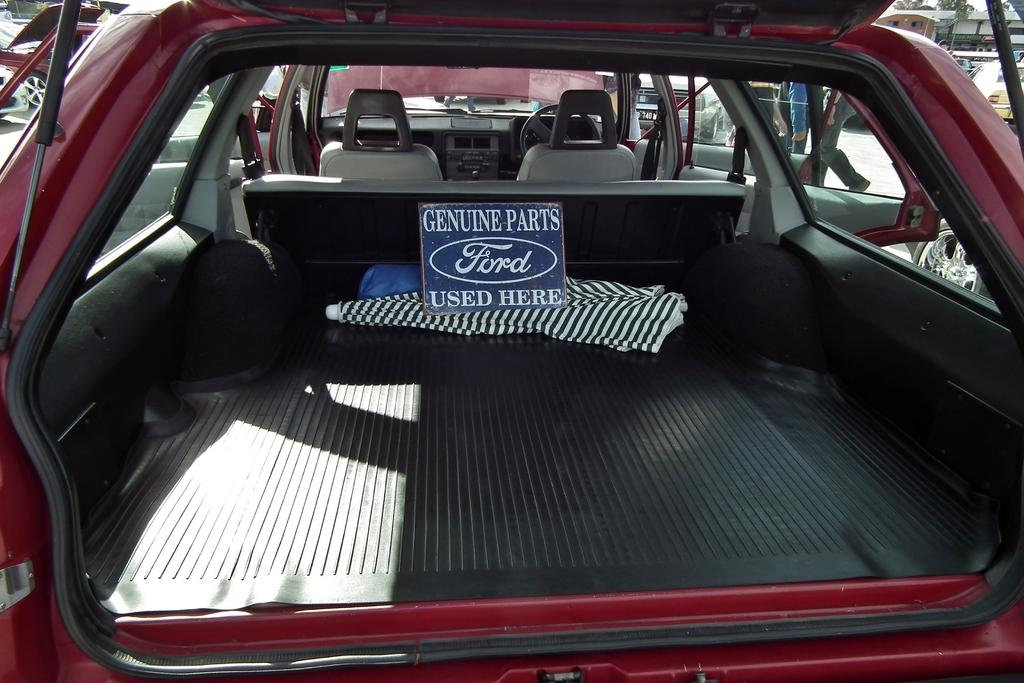What is the main subject of the image? The main subject of the image is a car. What is the state of the car's doors? The car has all its doors opened. What other objects can be seen in the image? There is a board, an umbrella, vehicles parked, a building, and trees visible in the image. What type of cakes are being served at the meeting in the image? There is no meeting or cakes present in the image. How does the water flow in the image? There is no water present in the image. 